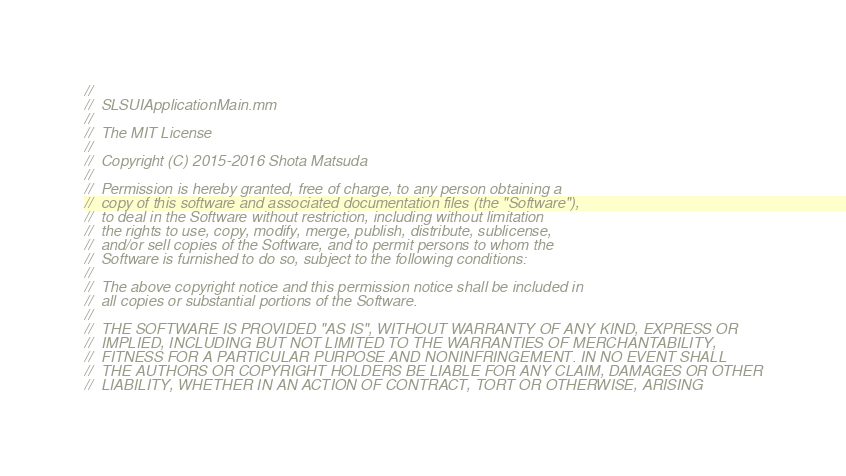<code> <loc_0><loc_0><loc_500><loc_500><_ObjectiveC_>//
//  SLSUIApplicationMain.mm
//
//  The MIT License
//
//  Copyright (C) 2015-2016 Shota Matsuda
//
//  Permission is hereby granted, free of charge, to any person obtaining a
//  copy of this software and associated documentation files (the "Software"),
//  to deal in the Software without restriction, including without limitation
//  the rights to use, copy, modify, merge, publish, distribute, sublicense,
//  and/or sell copies of the Software, and to permit persons to whom the
//  Software is furnished to do so, subject to the following conditions:
//
//  The above copyright notice and this permission notice shall be included in
//  all copies or substantial portions of the Software.
//
//  THE SOFTWARE IS PROVIDED "AS IS", WITHOUT WARRANTY OF ANY KIND, EXPRESS OR
//  IMPLIED, INCLUDING BUT NOT LIMITED TO THE WARRANTIES OF MERCHANTABILITY,
//  FITNESS FOR A PARTICULAR PURPOSE AND NONINFRINGEMENT. IN NO EVENT SHALL
//  THE AUTHORS OR COPYRIGHT HOLDERS BE LIABLE FOR ANY CLAIM, DAMAGES OR OTHER
//  LIABILITY, WHETHER IN AN ACTION OF CONTRACT, TORT OR OTHERWISE, ARISING</code> 